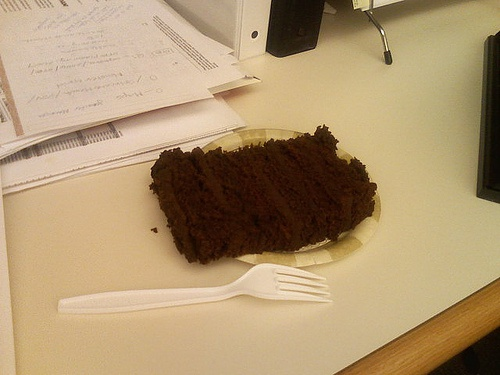Describe the objects in this image and their specific colors. I can see cake in tan, black, and maroon tones, fork in tan and beige tones, and book in tan tones in this image. 